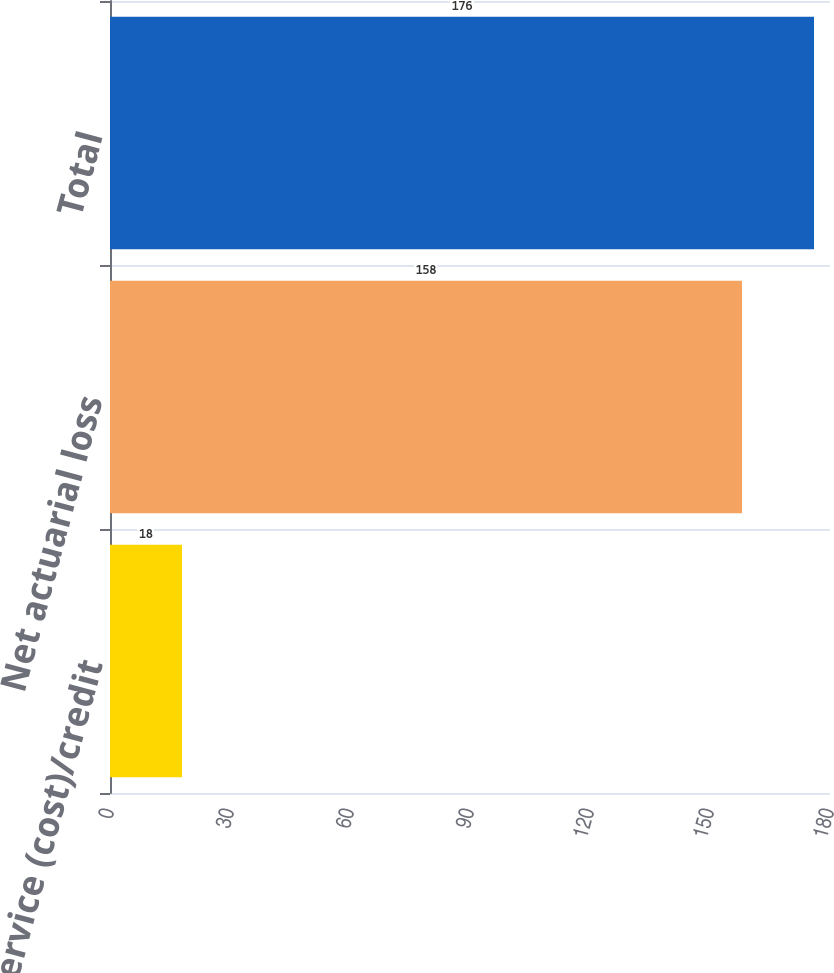Convert chart. <chart><loc_0><loc_0><loc_500><loc_500><bar_chart><fcel>Prior service (cost)/credit<fcel>Net actuarial loss<fcel>Total<nl><fcel>18<fcel>158<fcel>176<nl></chart> 